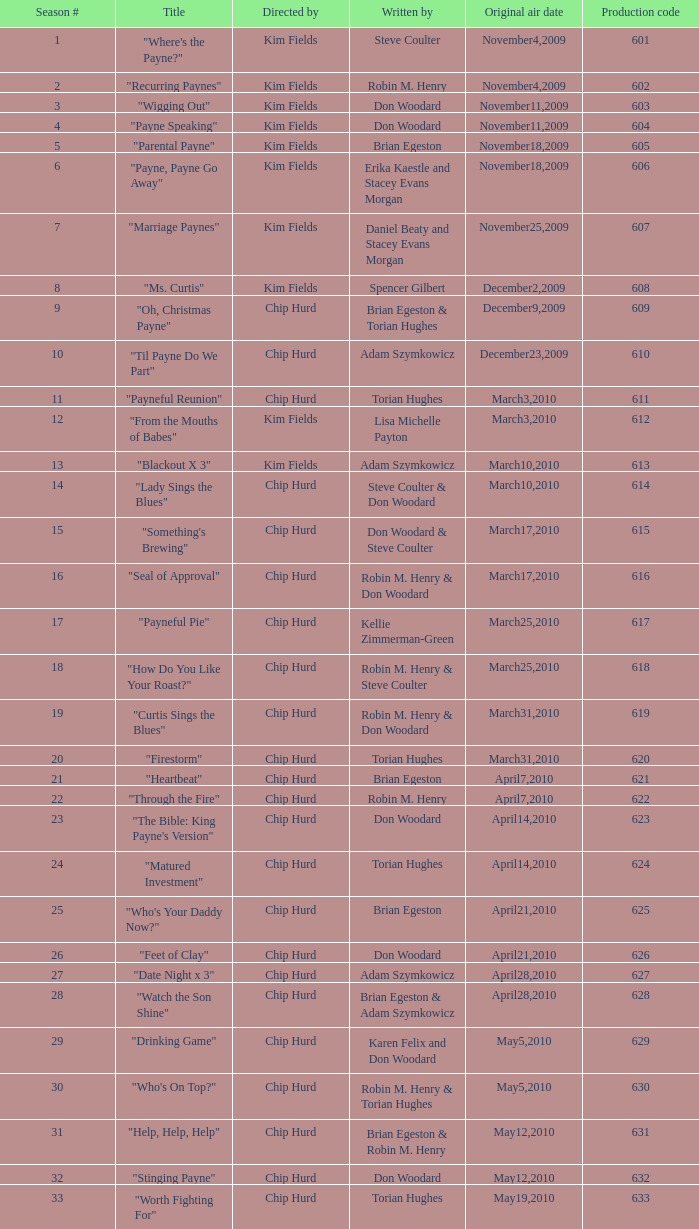What is the original broadcast dates for the title "firestorm"? March31,2010. I'm looking to parse the entire table for insights. Could you assist me with that? {'header': ['Season #', 'Title', 'Directed by', 'Written by', 'Original air date', 'Production code'], 'rows': [['1', '"Where\'s the Payne?"', 'Kim Fields', 'Steve Coulter', 'November4,2009', '601'], ['2', '"Recurring Paynes"', 'Kim Fields', 'Robin M. Henry', 'November4,2009', '602'], ['3', '"Wigging Out"', 'Kim Fields', 'Don Woodard', 'November11,2009', '603'], ['4', '"Payne Speaking"', 'Kim Fields', 'Don Woodard', 'November11,2009', '604'], ['5', '"Parental Payne"', 'Kim Fields', 'Brian Egeston', 'November18,2009', '605'], ['6', '"Payne, Payne Go Away"', 'Kim Fields', 'Erika Kaestle and Stacey Evans Morgan', 'November18,2009', '606'], ['7', '"Marriage Paynes"', 'Kim Fields', 'Daniel Beaty and Stacey Evans Morgan', 'November25,2009', '607'], ['8', '"Ms. Curtis"', 'Kim Fields', 'Spencer Gilbert', 'December2,2009', '608'], ['9', '"Oh, Christmas Payne"', 'Chip Hurd', 'Brian Egeston & Torian Hughes', 'December9,2009', '609'], ['10', '"Til Payne Do We Part"', 'Chip Hurd', 'Adam Szymkowicz', 'December23,2009', '610'], ['11', '"Payneful Reunion"', 'Chip Hurd', 'Torian Hughes', 'March3,2010', '611'], ['12', '"From the Mouths of Babes"', 'Kim Fields', 'Lisa Michelle Payton', 'March3,2010', '612'], ['13', '"Blackout X 3"', 'Kim Fields', 'Adam Szymkowicz', 'March10,2010', '613'], ['14', '"Lady Sings the Blues"', 'Chip Hurd', 'Steve Coulter & Don Woodard', 'March10,2010', '614'], ['15', '"Something\'s Brewing"', 'Chip Hurd', 'Don Woodard & Steve Coulter', 'March17,2010', '615'], ['16', '"Seal of Approval"', 'Chip Hurd', 'Robin M. Henry & Don Woodard', 'March17,2010', '616'], ['17', '"Payneful Pie"', 'Chip Hurd', 'Kellie Zimmerman-Green', 'March25,2010', '617'], ['18', '"How Do You Like Your Roast?"', 'Chip Hurd', 'Robin M. Henry & Steve Coulter', 'March25,2010', '618'], ['19', '"Curtis Sings the Blues"', 'Chip Hurd', 'Robin M. Henry & Don Woodard', 'March31,2010', '619'], ['20', '"Firestorm"', 'Chip Hurd', 'Torian Hughes', 'March31,2010', '620'], ['21', '"Heartbeat"', 'Chip Hurd', 'Brian Egeston', 'April7,2010', '621'], ['22', '"Through the Fire"', 'Chip Hurd', 'Robin M. Henry', 'April7,2010', '622'], ['23', '"The Bible: King Payne\'s Version"', 'Chip Hurd', 'Don Woodard', 'April14,2010', '623'], ['24', '"Matured Investment"', 'Chip Hurd', 'Torian Hughes', 'April14,2010', '624'], ['25', '"Who\'s Your Daddy Now?"', 'Chip Hurd', 'Brian Egeston', 'April21,2010', '625'], ['26', '"Feet of Clay"', 'Chip Hurd', 'Don Woodard', 'April21,2010', '626'], ['27', '"Date Night x 3"', 'Chip Hurd', 'Adam Szymkowicz', 'April28,2010', '627'], ['28', '"Watch the Son Shine"', 'Chip Hurd', 'Brian Egeston & Adam Szymkowicz', 'April28,2010', '628'], ['29', '"Drinking Game"', 'Chip Hurd', 'Karen Felix and Don Woodard', 'May5,2010', '629'], ['30', '"Who\'s On Top?"', 'Chip Hurd', 'Robin M. Henry & Torian Hughes', 'May5,2010', '630'], ['31', '"Help, Help, Help"', 'Chip Hurd', 'Brian Egeston & Robin M. Henry', 'May12,2010', '631'], ['32', '"Stinging Payne"', 'Chip Hurd', 'Don Woodard', 'May12,2010', '632'], ['33', '"Worth Fighting For"', 'Chip Hurd', 'Torian Hughes', 'May19,2010', '633'], ['34', '"Who\'s Your Nanny?"', 'Chip Hurd', 'Robin M. Henry & Adam Szymkowicz', 'May19,2010', '634'], ['35', '"The Chef"', 'Chip Hurd', 'Anthony C. Hill', 'May26,2010', '635'], ['36', '"My Fair Curtis"', 'Chip Hurd', 'Don Woodard', 'May26,2010', '636'], ['37', '"Rest for the Weary"', 'Chip Hurd', 'Brian Egeston', 'June2,2010', '637'], ['38', '"Thug Life"', 'Chip Hurd', 'Torian Hughes', 'June2,2010', '638'], ['39', '"Rehabilitation"', 'Chip Hurd', 'Adam Szymkowicz', 'June9,2010', '639'], ['40', '"A Payne In Need Is A Pain Indeed"', 'Chip Hurd', 'Don Woodard', 'June9,2010', '640'], ['41', '"House Guest"', 'Chip Hurd', 'David A. Arnold', 'January5,2011', '641'], ['42', '"Payne Showers"', 'Chip Hurd', 'Omega Mariaunnie Stewart and Torian Hughes', 'January5,2011', '642'], ['43', '"Playing With Fire"', 'Chip Hurd', 'Carlos Portugal', 'January12,2011', '643'], ['44', '"When the Payne\'s Away"', 'Chip Hurd', 'Kristin Topps and Don Woodard', 'January12,2011', '644'], ['45', '"Beginnings"', 'Chip Hurd', 'Myra J.', 'January19,2011', '645']]} 